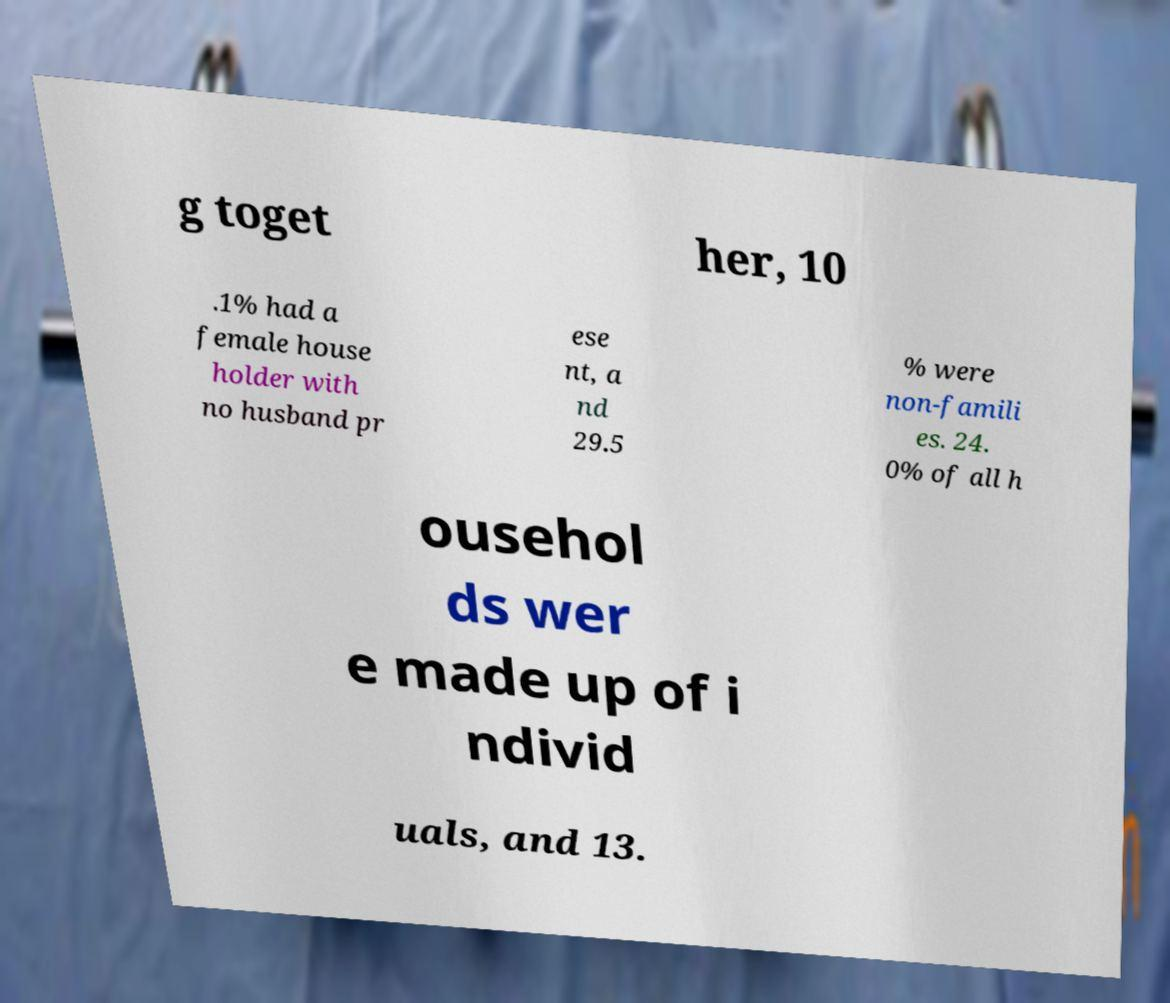What messages or text are displayed in this image? I need them in a readable, typed format. g toget her, 10 .1% had a female house holder with no husband pr ese nt, a nd 29.5 % were non-famili es. 24. 0% of all h ousehol ds wer e made up of i ndivid uals, and 13. 